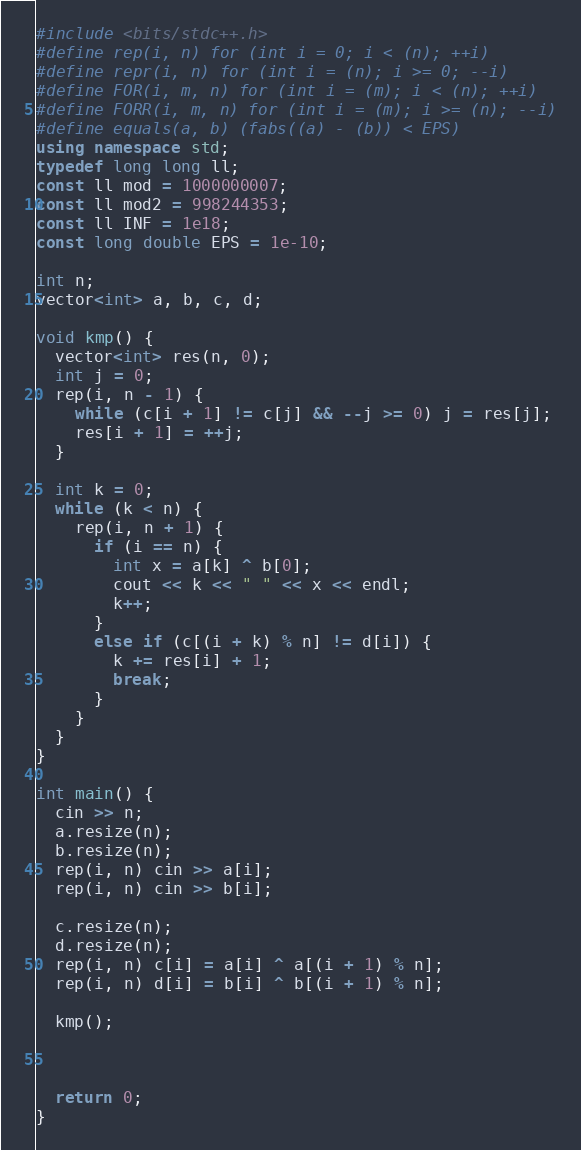Convert code to text. <code><loc_0><loc_0><loc_500><loc_500><_C++_>#include <bits/stdc++.h>
#define rep(i, n) for (int i = 0; i < (n); ++i)
#define repr(i, n) for (int i = (n); i >= 0; --i)
#define FOR(i, m, n) for (int i = (m); i < (n); ++i)
#define FORR(i, m, n) for (int i = (m); i >= (n); --i)
#define equals(a, b) (fabs((a) - (b)) < EPS)
using namespace std;
typedef long long ll;
const ll mod = 1000000007;
const ll mod2 = 998244353;
const ll INF = 1e18;
const long double EPS = 1e-10;

int n;
vector<int> a, b, c, d;

void kmp() {
  vector<int> res(n, 0);
  int j = 0;
  rep(i, n - 1) {
    while (c[i + 1] != c[j] && --j >= 0) j = res[j];
    res[i + 1] = ++j;
  }
  
  int k = 0;
  while (k < n) {
    rep(i, n + 1) {
      if (i == n) {
        int x = a[k] ^ b[0];
        cout << k << " " << x << endl;
        k++;
      }
      else if (c[(i + k) % n] != d[i]) {
        k += res[i] + 1;
        break;
      }
    }
  }
}

int main() {
  cin >> n;
  a.resize(n);
  b.resize(n);
  rep(i, n) cin >> a[i];
  rep(i, n) cin >> b[i];

  c.resize(n);
  d.resize(n);
  rep(i, n) c[i] = a[i] ^ a[(i + 1) % n];
  rep(i, n) d[i] = b[i] ^ b[(i + 1) % n];

  kmp();


  
  return 0;
}</code> 